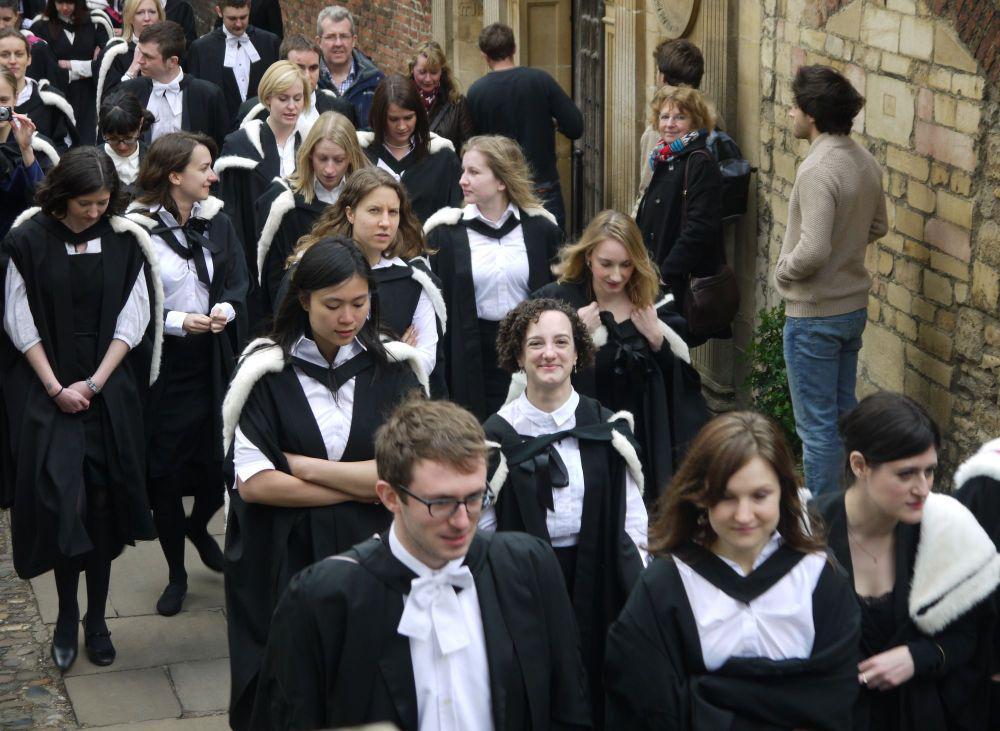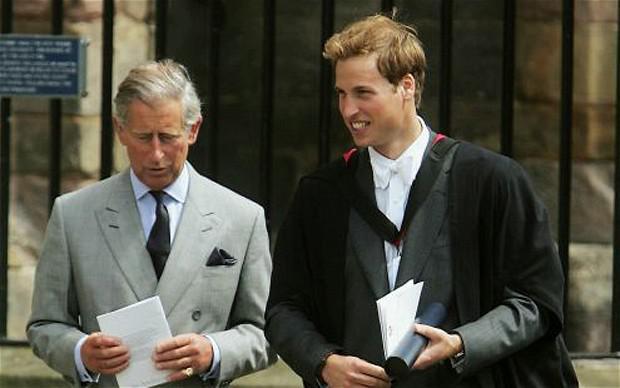The first image is the image on the left, the second image is the image on the right. Evaluate the accuracy of this statement regarding the images: "The left image contains no more than two graduation students.". Is it true? Answer yes or no. No. The first image is the image on the left, the second image is the image on the right. Examine the images to the left and right. Is the description "An image contains one front-facing graduate, a young man wearing a white bow around his neck and no cap." accurate? Answer yes or no. No. 